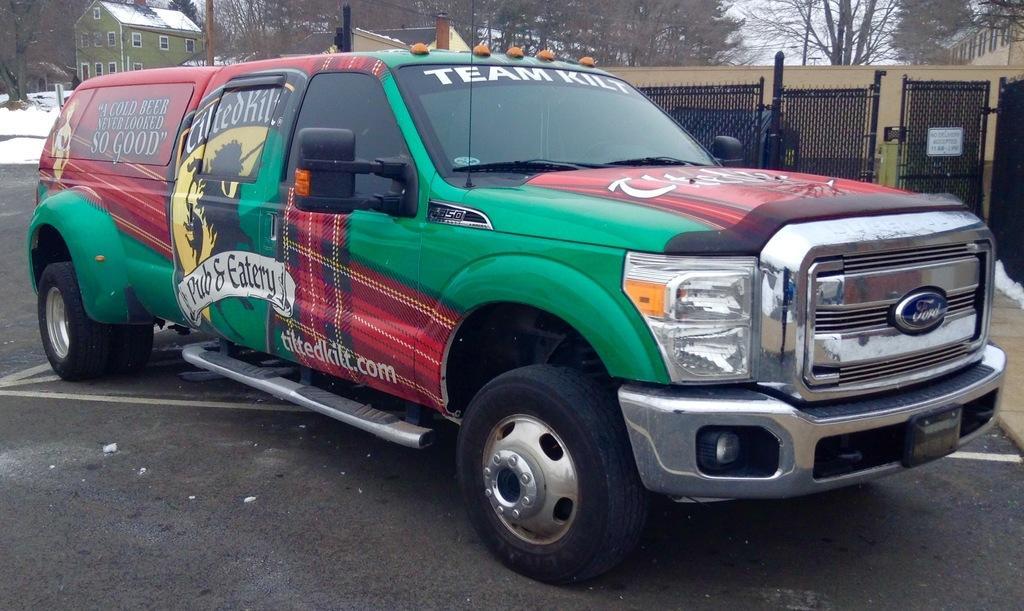Describe this image in one or two sentences. In this picture I can observe a vehicle on the road. This vehicle is in green, red and black colors. In the background there are trees and a house. 